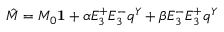Convert formula to latex. <formula><loc_0><loc_0><loc_500><loc_500>\hat { M } = M _ { 0 } { 1 } + \alpha E _ { 3 } ^ { + } E _ { 3 } ^ { - } q ^ { Y } + \beta E _ { 3 } ^ { - } E _ { 3 } ^ { + } q ^ { Y }</formula> 